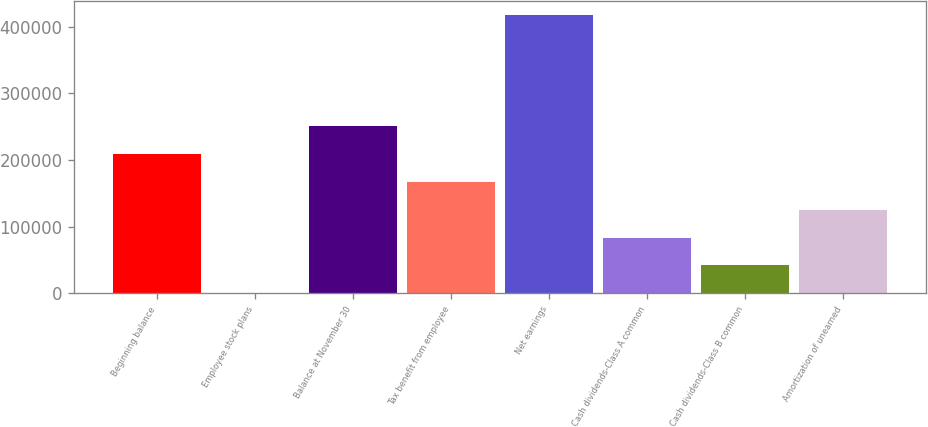<chart> <loc_0><loc_0><loc_500><loc_500><bar_chart><fcel>Beginning balance<fcel>Employee stock plans<fcel>Balance at November 30<fcel>Tax benefit from employee<fcel>Net earnings<fcel>Cash dividends-Class A common<fcel>Cash dividends-Class B common<fcel>Amortization of unearned<nl><fcel>209050<fcel>256<fcel>250809<fcel>167292<fcel>417845<fcel>83773.8<fcel>42014.9<fcel>125533<nl></chart> 